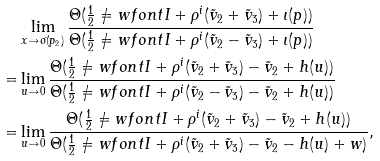Convert formula to latex. <formula><loc_0><loc_0><loc_500><loc_500>& \lim _ { x \to \sigma ( p _ { 2 } ) } \frac { \Theta ( \frac { 1 } { 2 } \ne w f o n t I + \rho ^ { i } ( \tilde { v } _ { 2 } + \tilde { v } _ { 3 } ) + \iota ( p ) ) } { \Theta ( \frac { 1 } { 2 } \ne w f o n t I + \rho ^ { i } ( \tilde { v } _ { 2 } - \tilde { v } _ { 3 } ) + \iota ( p ) ) } \\ = & \lim _ { u \to 0 } \frac { \Theta ( \frac { 1 } { 2 } \ne w f o n t I + \rho ^ { i } ( \tilde { v } _ { 2 } + \tilde { v } _ { 3 } ) - \tilde { v } _ { 2 } + h ( u ) ) } { \Theta ( \frac { 1 } { 2 } \ne w f o n t I + \rho ^ { i } ( \tilde { v } _ { 2 } - \tilde { v } _ { 3 } ) - \tilde { v } _ { 2 } + h ( u ) ) } \\ = & \lim _ { u \to 0 } \frac { \Theta ( \frac { 1 } { 2 } \ne w f o n t I + \rho ^ { i } ( \tilde { v } _ { 2 } + \tilde { v } _ { 3 } ) - \tilde { v } _ { 2 } + h ( u ) ) } { \Theta ( \frac { 1 } { 2 } \ne w f o n t I + \rho ^ { i } ( \tilde { v } _ { 2 } + \tilde { v } _ { 3 } ) - \tilde { v } _ { 2 } - h ( u ) + w ) } ,</formula> 